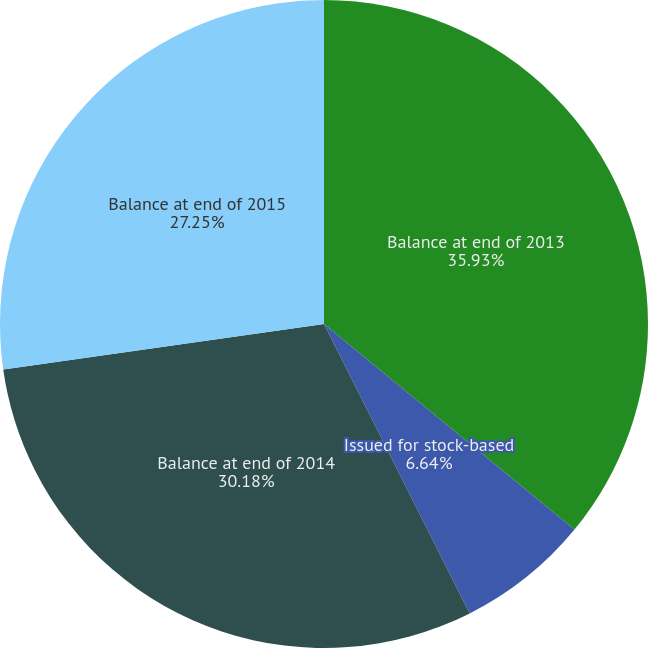Convert chart to OTSL. <chart><loc_0><loc_0><loc_500><loc_500><pie_chart><fcel>Balance at end of 2013<fcel>Issued for stock-based<fcel>Balance at end of 2014<fcel>Balance at end of 2015<nl><fcel>35.94%<fcel>6.64%<fcel>30.18%<fcel>27.25%<nl></chart> 